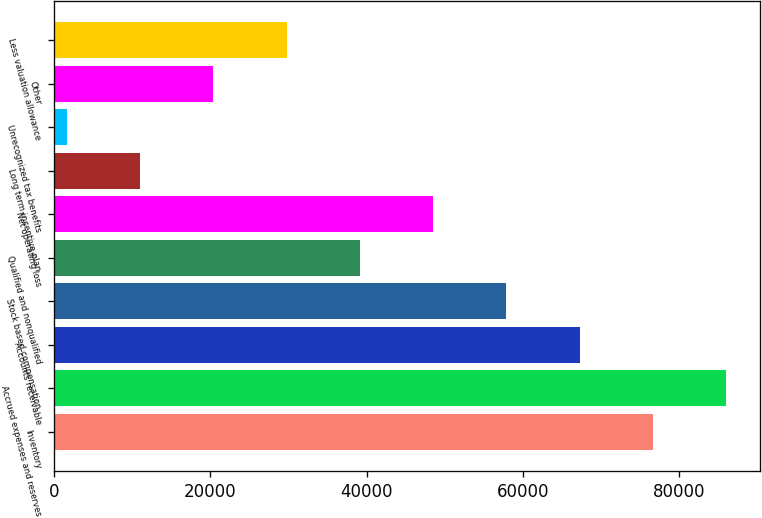Convert chart. <chart><loc_0><loc_0><loc_500><loc_500><bar_chart><fcel>Inventory<fcel>Accrued expenses and reserves<fcel>Accounts receivable<fcel>Stock based compensation<fcel>Qualified and nonqualified<fcel>Net operating loss<fcel>Long term incentive plan<fcel>Unrecognized tax benefits<fcel>Other<fcel>Less valuation allowance<nl><fcel>76601<fcel>85969<fcel>67233<fcel>57865<fcel>39129<fcel>48497<fcel>11025<fcel>1657<fcel>20393<fcel>29761<nl></chart> 